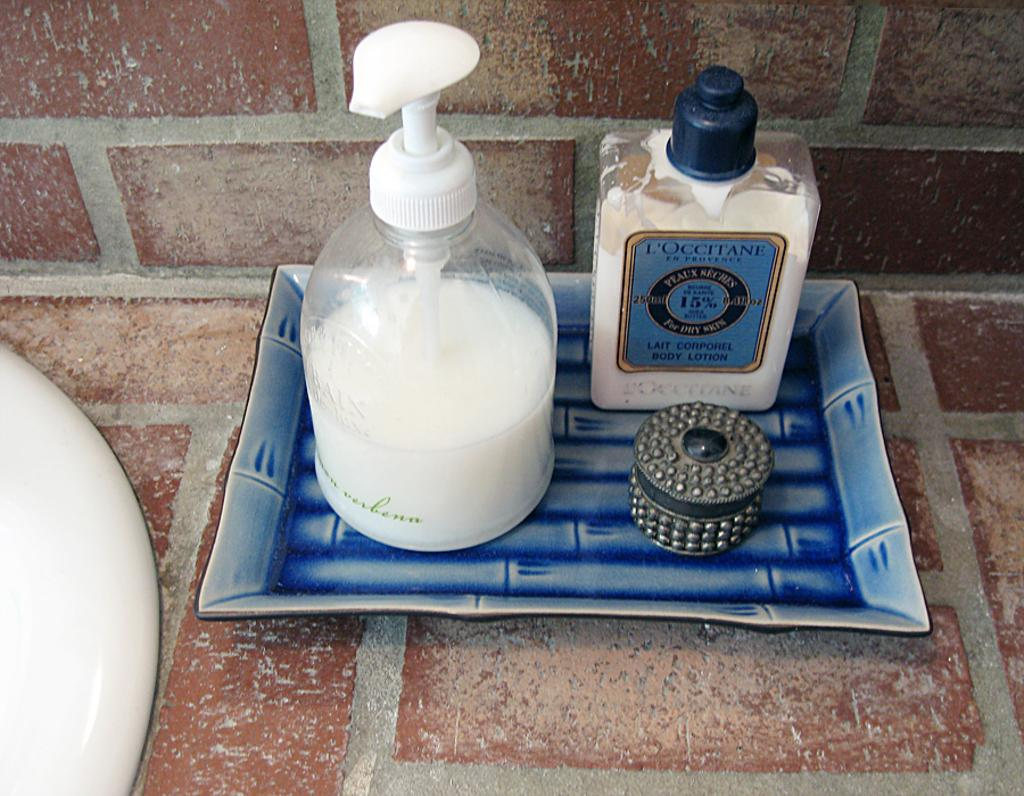What is present on the plate in the image? There are two bottles with a white color solution on the plate. What else can be seen in the image besides the plate and bottles? There is a small box with a metal body in the image. What type of battle is taking place in the image? There is no battle present in the image; it only features a plate with two bottles and a small metal box. Can you describe the dirt or soil in the image? There is no dirt or soil present in the image. What type of sponge is being used to clean the metal box in the image? There is no sponge present in the image, nor is there any cleaning activity depicted. 